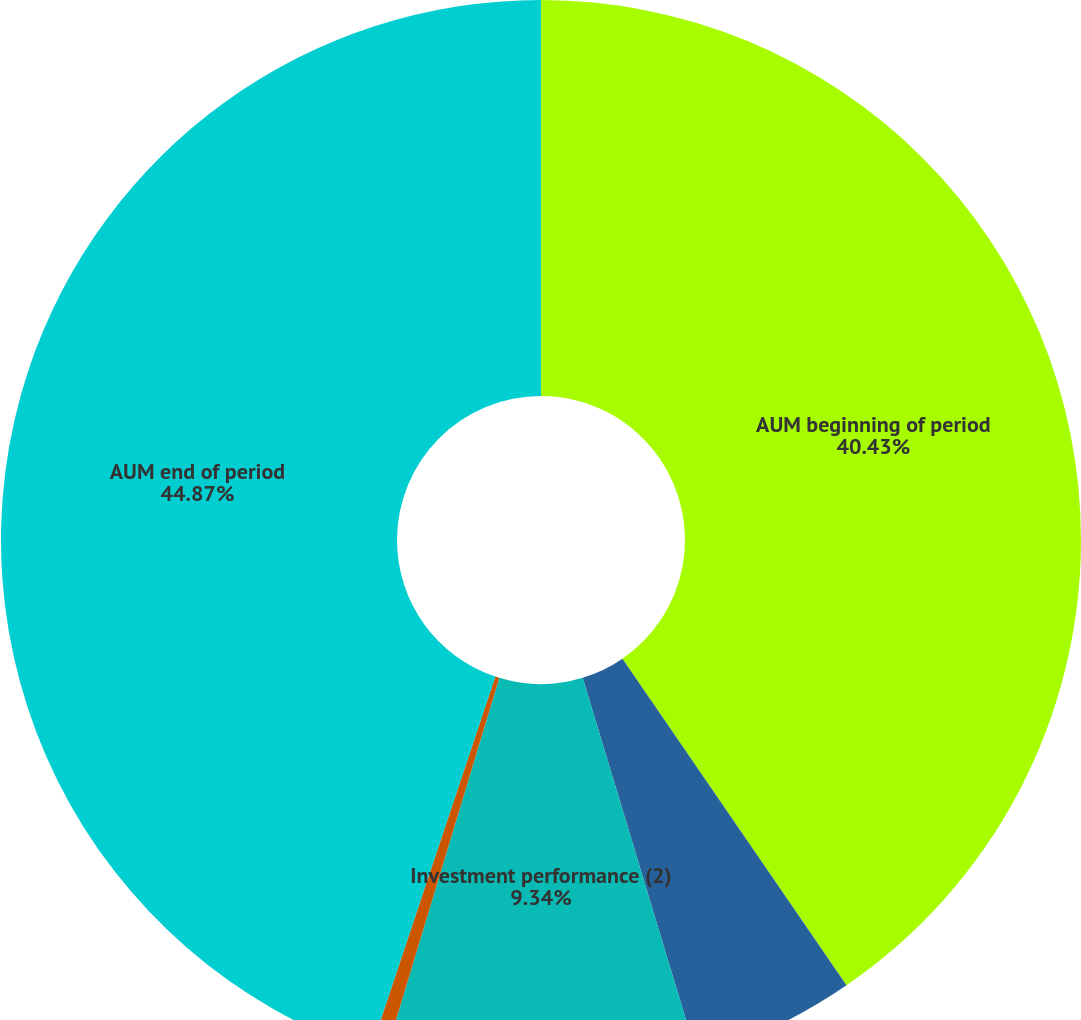Convert chart to OTSL. <chart><loc_0><loc_0><loc_500><loc_500><pie_chart><fcel>AUM beginning of period<fcel>Net cash flow (1)<fcel>Investment performance (2)<fcel>Other (4)<fcel>AUM end of period<nl><fcel>40.43%<fcel>4.9%<fcel>9.34%<fcel>0.46%<fcel>44.87%<nl></chart> 